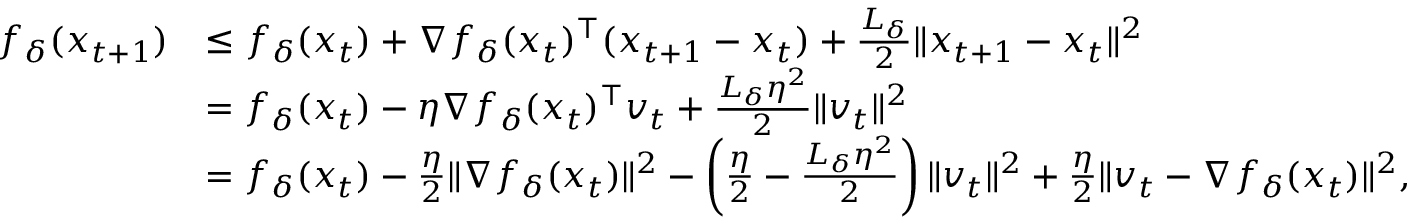<formula> <loc_0><loc_0><loc_500><loc_500>\begin{array} { r l } { f _ { \delta } ( x _ { t + 1 } ) } & { \leq f _ { \delta } ( x _ { t } ) + \nabla f _ { \delta } ( x _ { t } ) ^ { \top } ( x _ { t + 1 } - x _ { t } ) + \frac { L _ { \delta } } { 2 } \| x _ { t + 1 } - x _ { t } \| ^ { 2 } } \\ & { = f _ { \delta } ( x _ { t } ) - \eta \nabla f _ { \delta } ( x _ { t } ) ^ { \top } v _ { t } + \frac { L _ { \delta } \eta ^ { 2 } } { 2 } \| v _ { t } \| ^ { 2 } } \\ & { = f _ { \delta } ( x _ { t } ) - \frac { \eta } { 2 } \| \nabla f _ { \delta } ( x _ { t } ) \| ^ { 2 } - \left ( \frac { \eta } { 2 } - \frac { L _ { \delta } \eta ^ { 2 } } { 2 } \right ) \| v _ { t } \| ^ { 2 } + \frac { \eta } { 2 } \| v _ { t } - \nabla f _ { \delta } ( x _ { t } ) \| ^ { 2 } , } \end{array}</formula> 